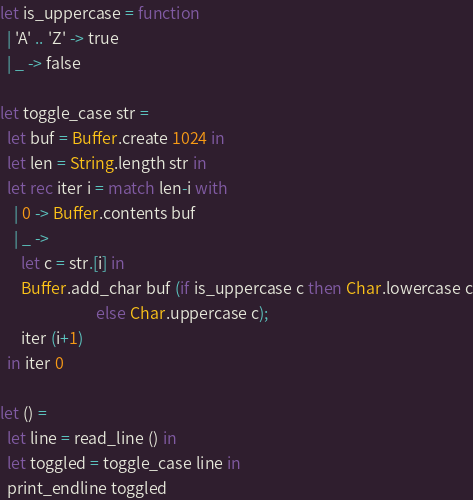Convert code to text. <code><loc_0><loc_0><loc_500><loc_500><_OCaml_>let is_uppercase = function
  | 'A' .. 'Z' -> true
  | _ -> false

let toggle_case str =
  let buf = Buffer.create 1024 in
  let len = String.length str in
  let rec iter i = match len-i with
    | 0 -> Buffer.contents buf
    | _ ->
      let c = str.[i] in
      Buffer.add_char buf (if is_uppercase c then Char.lowercase c
                           else Char.uppercase c);
      iter (i+1)
  in iter 0

let () =
  let line = read_line () in
  let toggled = toggle_case line in
  print_endline toggled</code> 